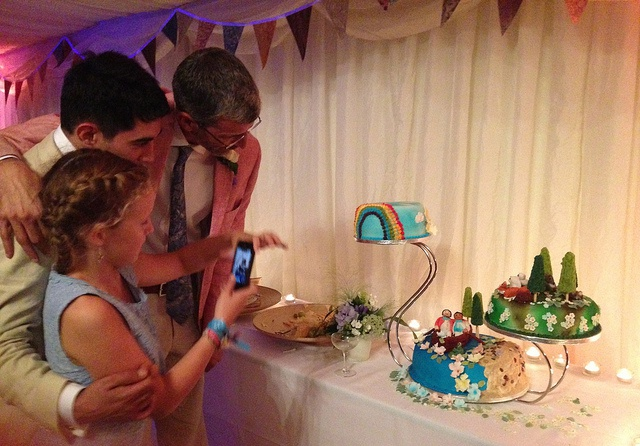Describe the objects in this image and their specific colors. I can see dining table in purple, tan, and gray tones, people in purple, maroon, black, and brown tones, people in purple, maroon, black, and brown tones, people in purple, black, maroon, tan, and brown tones, and cake in purple, tan, teal, and blue tones in this image. 